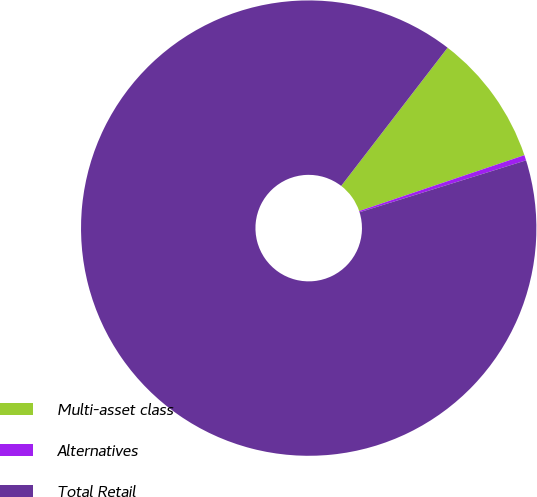<chart> <loc_0><loc_0><loc_500><loc_500><pie_chart><fcel>Multi-asset class<fcel>Alternatives<fcel>Total Retail<nl><fcel>9.37%<fcel>0.38%<fcel>90.25%<nl></chart> 